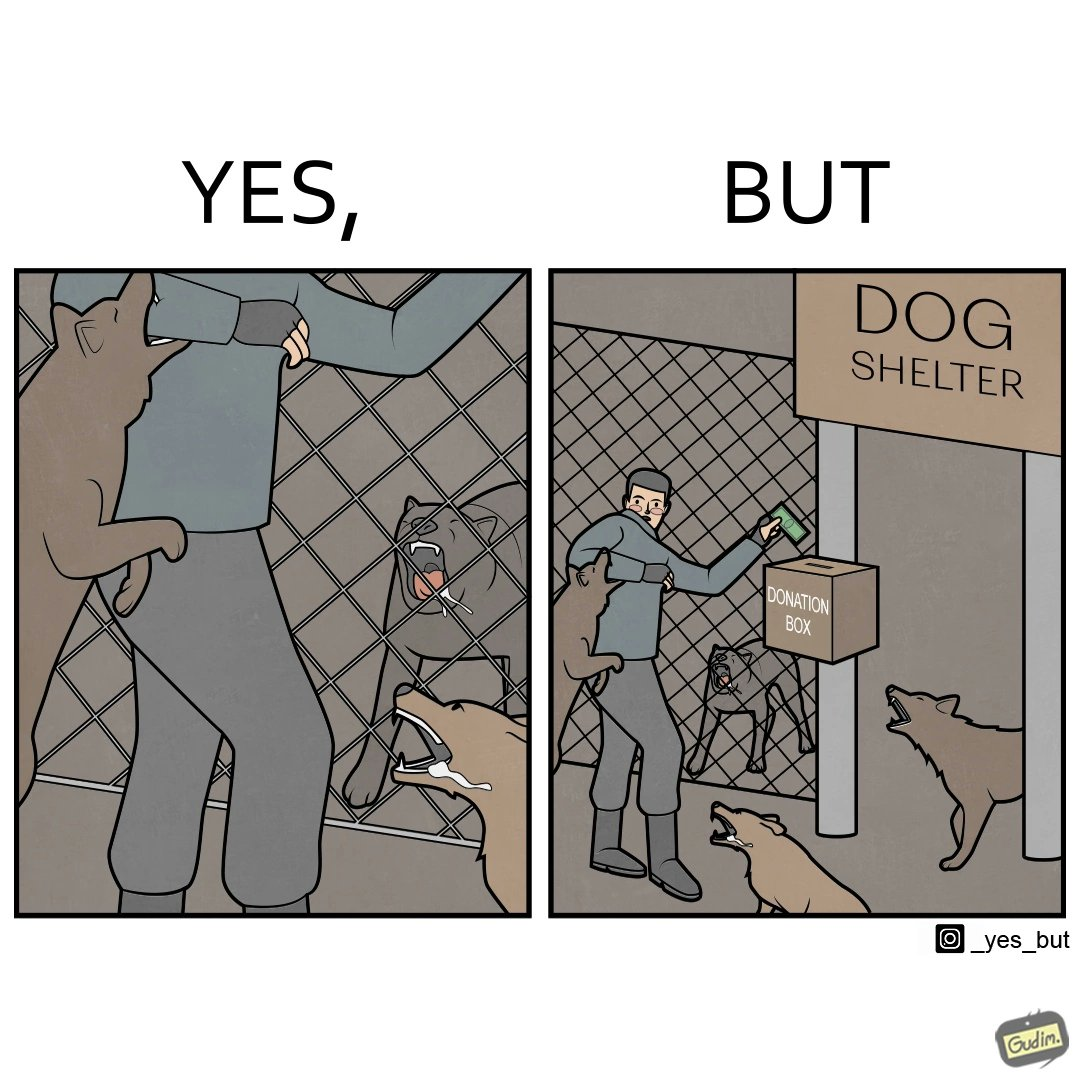What is the satirical meaning behind this image? The images are ironic since they show how dogs choose to attack a well wisher making a donation for helping dogs. It is sad that dogs mistake a well wisher and bite him while he is trying to help them. 